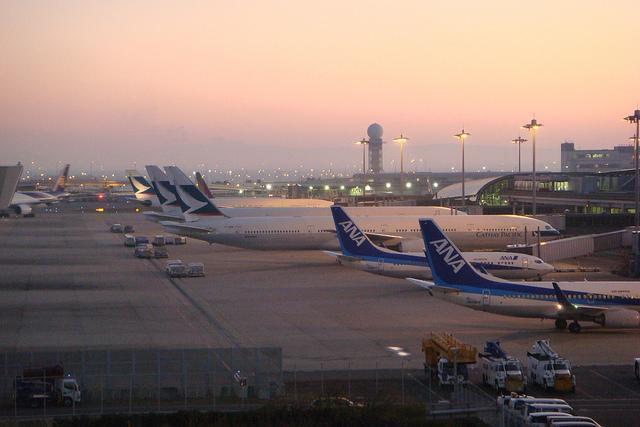How many planes are flying?
Give a very brief answer. 0. How many airplanes are at the gate?
Give a very brief answer. 5. How many airplanes can you see?
Give a very brief answer. 3. How many people are here?
Give a very brief answer. 0. 